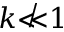Convert formula to latex. <formula><loc_0><loc_0><loc_500><loc_500>k \not \ll 1</formula> 